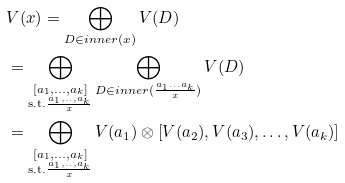<formula> <loc_0><loc_0><loc_500><loc_500>& V ( x ) = \bigoplus _ { D \in i n n e r ( x ) } V ( D ) \\ & = \bigoplus _ { \substack { [ a _ { 1 } , \dots , a _ { k } ] \\ \text {s.t.} \frac { a _ { 1 } , . . , a _ { k } } { x } } } \bigoplus _ { D \in i n n e r ( \frac { a _ { 1 } \dots a _ { k } } { x } ) } V ( D ) \\ & = \bigoplus _ { \substack { [ a _ { 1 } , \dots , a _ { k } ] \\ \text {s.t.} \frac { a _ { 1 } , . . , a _ { k } } { x } } } V ( a _ { 1 } ) \otimes \left [ V ( a _ { 2 } ) , V ( a _ { 3 } ) , \dots , V ( a _ { k } ) \right ]</formula> 